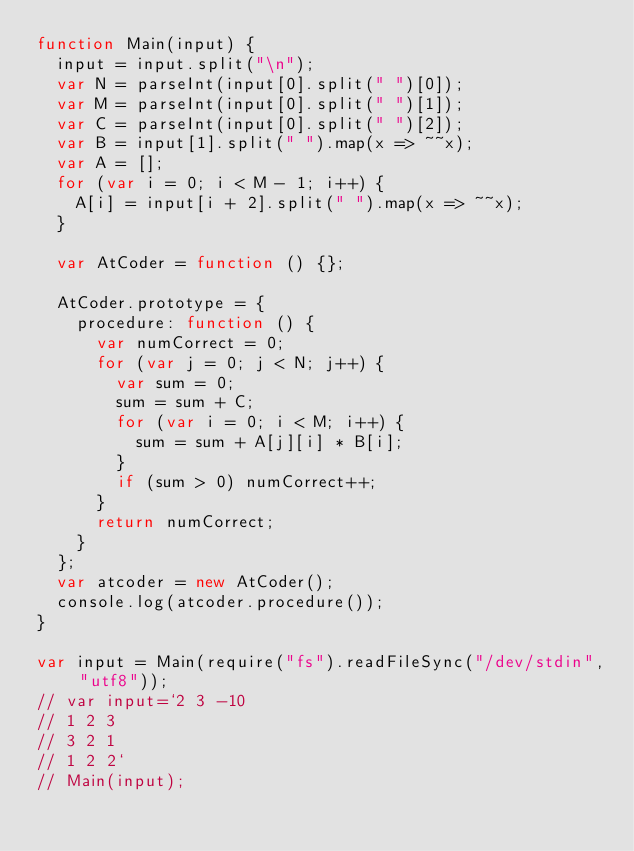Convert code to text. <code><loc_0><loc_0><loc_500><loc_500><_JavaScript_>function Main(input) {
  input = input.split("\n");
  var N = parseInt(input[0].split(" ")[0]);
  var M = parseInt(input[0].split(" ")[1]);
  var C = parseInt(input[0].split(" ")[2]);
  var B = input[1].split(" ").map(x => ~~x);
  var A = [];
  for (var i = 0; i < M - 1; i++) {
    A[i] = input[i + 2].split(" ").map(x => ~~x);
  }

  var AtCoder = function () {};

  AtCoder.prototype = {
    procedure: function () {
      var numCorrect = 0;
      for (var j = 0; j < N; j++) {
        var sum = 0;
        sum = sum + C;
        for (var i = 0; i < M; i++) {
          sum = sum + A[j][i] * B[i];
        }
        if (sum > 0) numCorrect++;
      }
      return numCorrect;
    }
  };
  var atcoder = new AtCoder();
  console.log(atcoder.procedure());
}

var input = Main(require("fs").readFileSync("/dev/stdin", "utf8"));
// var input=`2 3 -10
// 1 2 3
// 3 2 1
// 1 2 2`
// Main(input);
</code> 